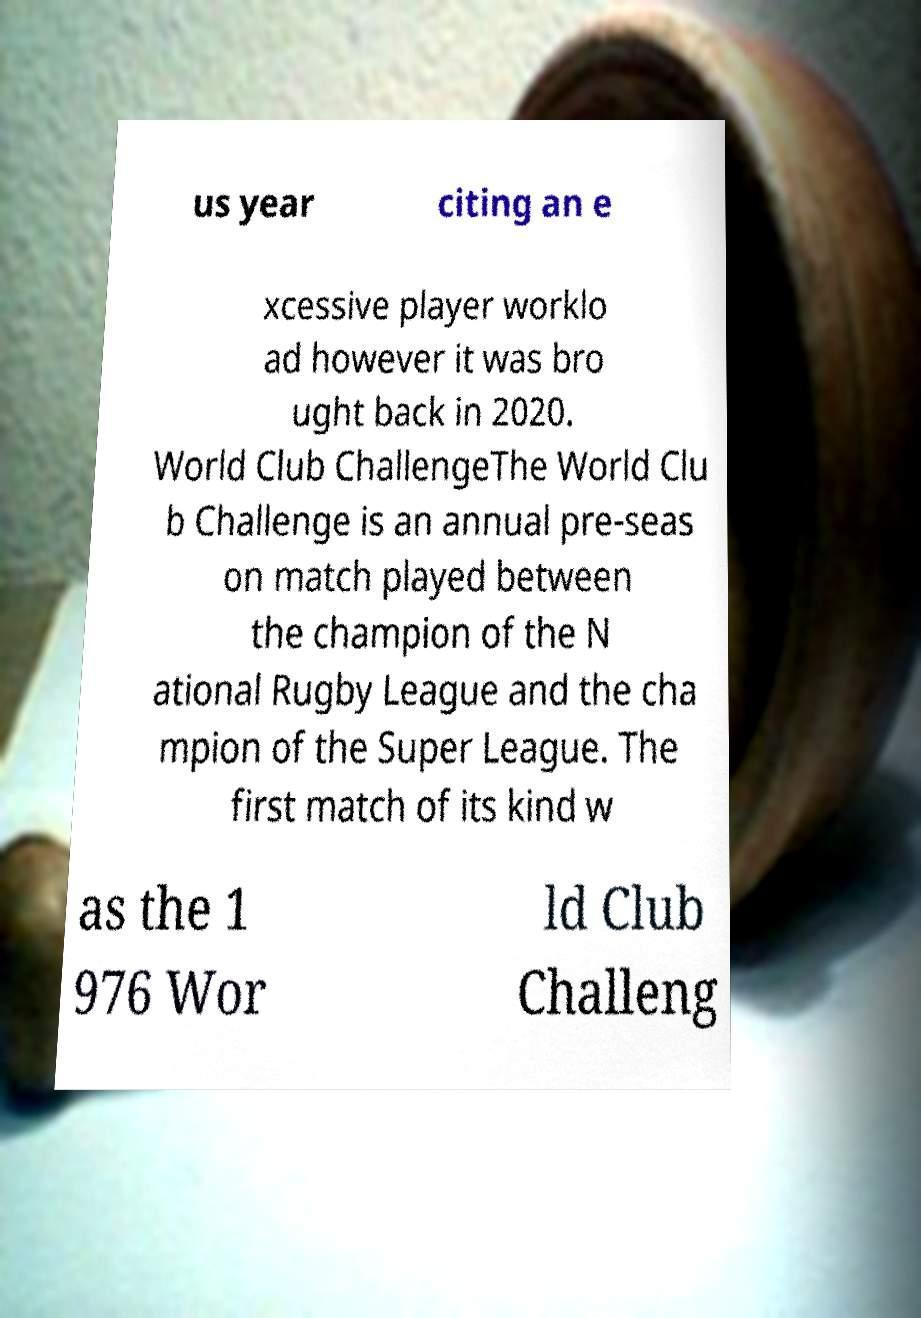Could you extract and type out the text from this image? us year citing an e xcessive player worklo ad however it was bro ught back in 2020. World Club ChallengeThe World Clu b Challenge is an annual pre-seas on match played between the champion of the N ational Rugby League and the cha mpion of the Super League. The first match of its kind w as the 1 976 Wor ld Club Challeng 